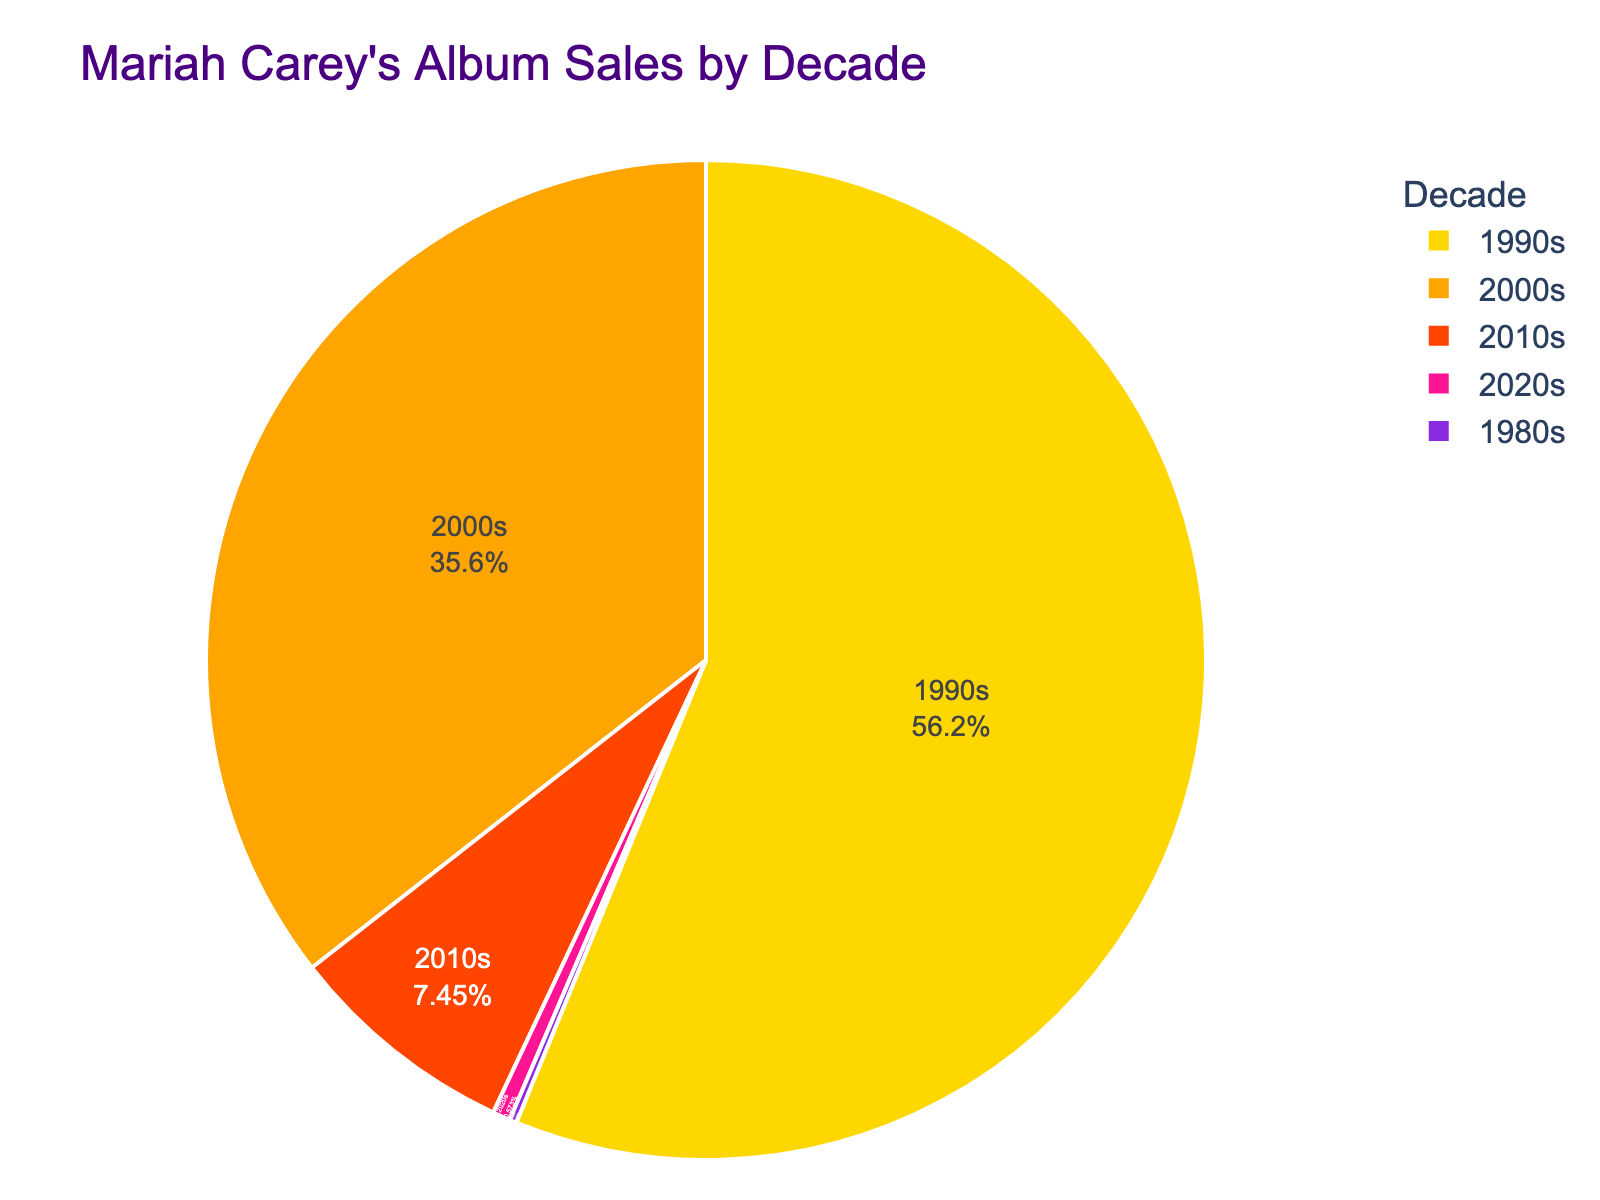Which decade had the highest album sales? By inspecting the pie chart, the largest section represents the 1990s, indicating that this decade had the highest album sales.
Answer: 1990s How much more album sales did the 1990s have compared to the 2000s? The pie chart shows 49,000,000 for the 1990s and 31,000,000 for the 2000s. Subtracting these values: 49,000,000 - 31,000,000 = 18,000,000.
Answer: 18,000,000 What fraction of total album sales occurred in the 2010s and beyond? Adding the sales from the 2010s (6,500,000) and the 2020s (500,000) gives 6,500,000 + 500,000 = 7,000,000. To find the fraction, we divide by the total sales (90,000,000): 7,000,000 / 90,000,000 ≈ 0.078 or 7.8%.
Answer: 7.8% Which decade's sales were closest to the combined sales of the 2000s and 2010s? First sum the sales of the 2000s (31,000,000) and 2010s (6,500,000) to get 37,500,000. Comparing this figure with other decades, the 1990s had 49,000,000 and are not close, while no individual decade matches this combined figure exactly.
Answer: None What percentage of Mariah Carey's album sales happened in the 2000s? The pie chart displays the proportion for each segment. The 2000s segment represents 31,000,000 out of 90,000,000. To find the percentage: (31,000,000 / 90,000,000) * 100 ≈ 34.4%.
Answer: 34.4% How do the album sales in the 1980s compare to those in the 2020s? The 1980s segment represents 200,000 sales and the 2020s segment represents 500,000 sales. Since 500,000 > 200,000, the 2020s sales are higher.
Answer: 2020s sales are higher If you sum the album sales of the 1980s, 2010s, and 2020s, what is the result? Summing the values for the 1980s (200,000), 2010s (6,500,000), and 2020s (500,000) gives us 200,000 + 6,500,000 + 500,000 = 7,200,000.
Answer: 7,200,000 What is the visual characteristic of the decade with the lowest album sales? The smallest segment of the pie chart represents the decade with the lowest sales. The 1980s has the smallest segment.
Answer: 1980s How would the new total album sales change if the 2020s sales doubled? Current 2020s sales = 500,000. If doubled, 500,000 * 2 = 1,000,000. Adding the increase to the total sales: Original total (90,000,000) - 500,000 + 1,000,000 = 90,500,000.
Answer: 90,500,000 